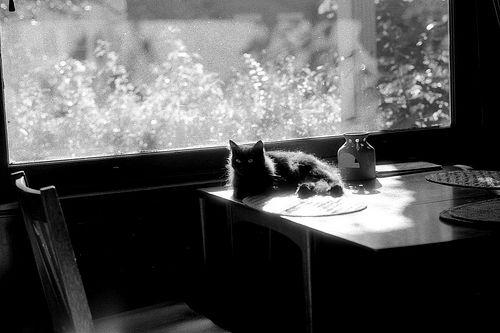How many place mats are there on the table? There are three place mats on the table. What is the central object in the image and what is its activity? The central object is a cat lying down on a table, next to a jar and a window. Describe the appearance of the cat and its location. The cat is black, with pointy ears and visible eyes. It is lying on a table next to a jar and a window. Is the image taken indoors or outdoors, and during what time of the day? The image is taken indoors during the day, with the sun coming in through the window. Count the number of distinct objects in the image and name them. There are eight distinct objects: cat, jar, chair, table, place mats, window, pole, and bushes. Explain the position of the chair in relation to the table. The chair is made of wood and located next to the table. Determine the material of the chair and table in the image. The chair is made of dark wood, while the table is a wooden dining table. Identify three objects that can be seen through the window. Bushes, a pole, and plants can be seen through the window. What kind of picture is the image, and what are its dimensions? It is a black and white picture with dimensions 404 pixels wide and 404 pixels high. Perform sentiment analysis on the image, and explain the overall feeling. The image has a cozy and warm feeling, with a cat lying on a table next to a jar in a sunlit room with a large window. Can you spot the vase of flowers on the table next to the jar and the cat? This vase has an interesting texture on it, look closer! Find the intricately carved wooden clock placed on the table next to the jar. The clock has Roman numerals on its dial. Where is the red book on the wooden shelf near the window? You will notice the title of the book is written in gold letters. How beautiful is the painting hanging on the wall next to the chair! Notice the detailed brushstrokes in the painting. Is there a plate with fruits on the table along with other items? The arrangement of fruits is quite artistic. Did you see the dog playing with a toy outside the window? The dog is wearing a cute collar! 